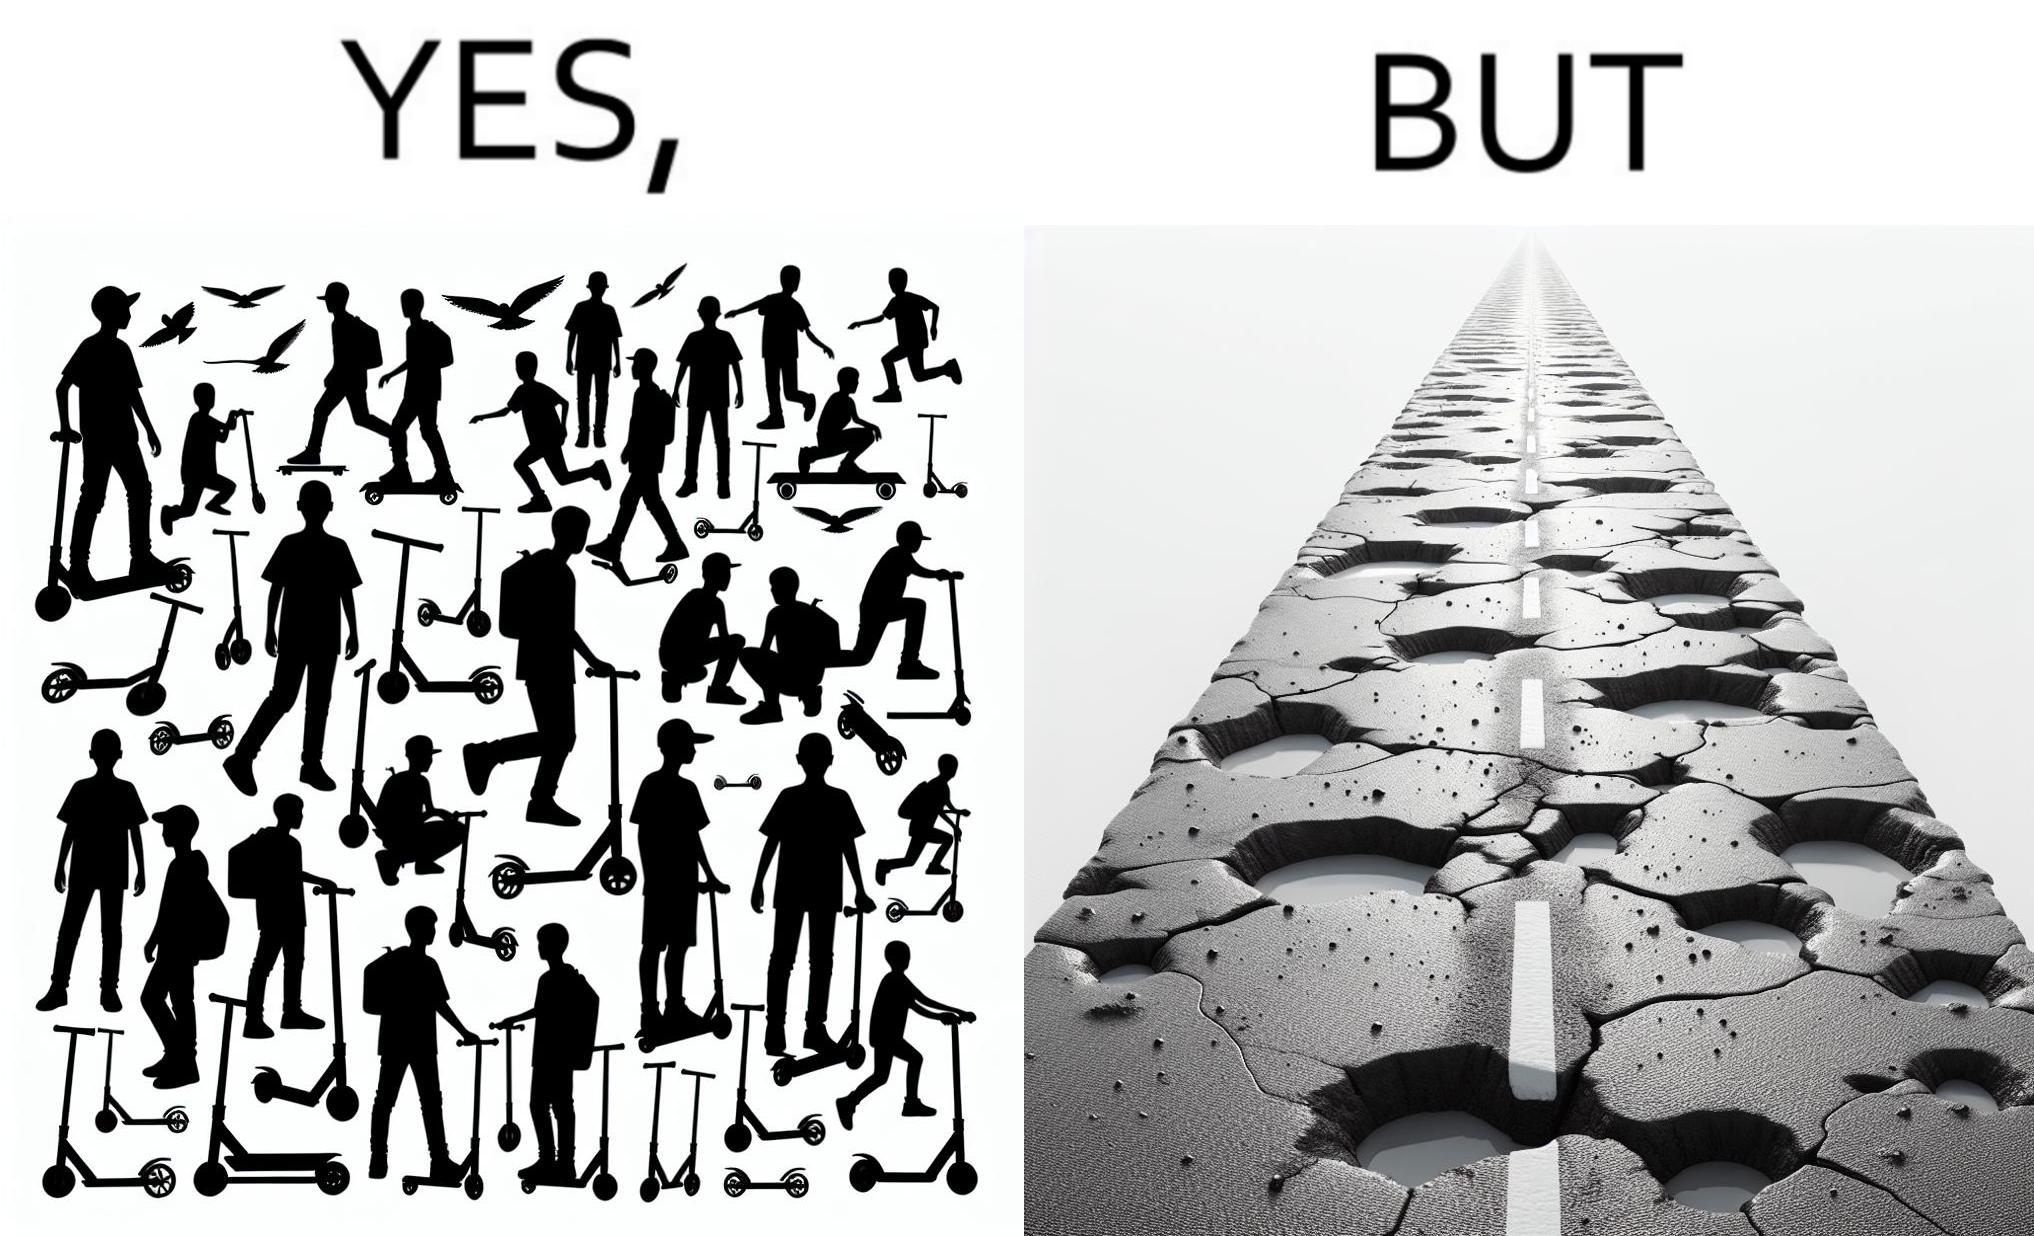Describe the satirical element in this image. The image is ironic, because even after when the skateboard scooters are available for someone to ride but the road has many potholes that it is not suitable to ride the scooters on such roads 